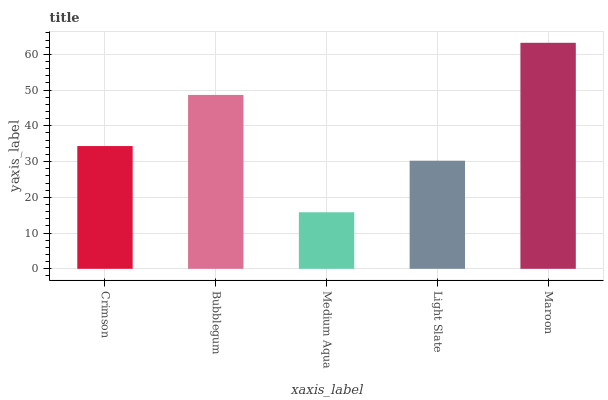Is Medium Aqua the minimum?
Answer yes or no. Yes. Is Maroon the maximum?
Answer yes or no. Yes. Is Bubblegum the minimum?
Answer yes or no. No. Is Bubblegum the maximum?
Answer yes or no. No. Is Bubblegum greater than Crimson?
Answer yes or no. Yes. Is Crimson less than Bubblegum?
Answer yes or no. Yes. Is Crimson greater than Bubblegum?
Answer yes or no. No. Is Bubblegum less than Crimson?
Answer yes or no. No. Is Crimson the high median?
Answer yes or no. Yes. Is Crimson the low median?
Answer yes or no. Yes. Is Maroon the high median?
Answer yes or no. No. Is Maroon the low median?
Answer yes or no. No. 